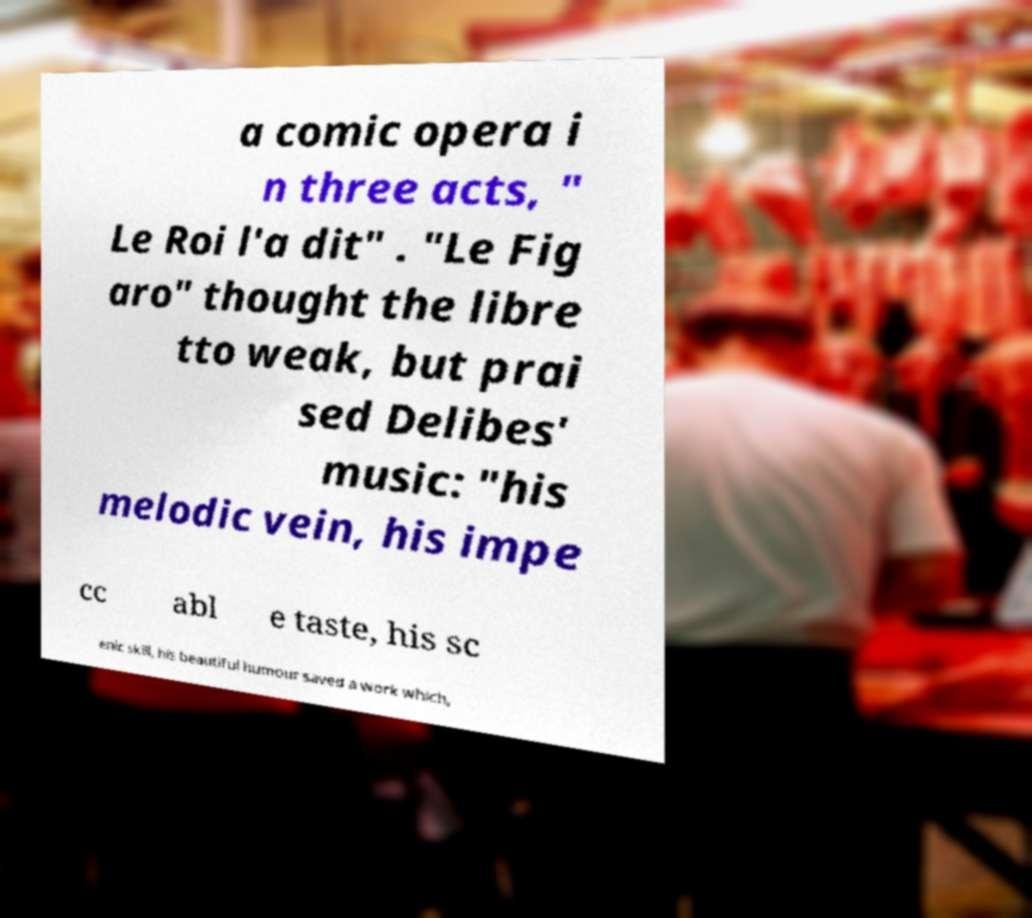For documentation purposes, I need the text within this image transcribed. Could you provide that? a comic opera i n three acts, " Le Roi l'a dit" . "Le Fig aro" thought the libre tto weak, but prai sed Delibes' music: "his melodic vein, his impe cc abl e taste, his sc enic skill, his beautiful humour saved a work which, 